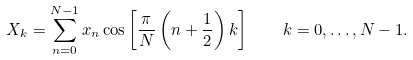Convert formula to latex. <formula><loc_0><loc_0><loc_500><loc_500>X _ { k } = \sum _ { n = 0 } ^ { N - 1 } x _ { n } \cos \left [ { \frac { \pi } { N } } \left ( n + { \frac { 1 } { 2 } } \right ) k \right ] \quad k = 0 , \dots , N - 1 .</formula> 